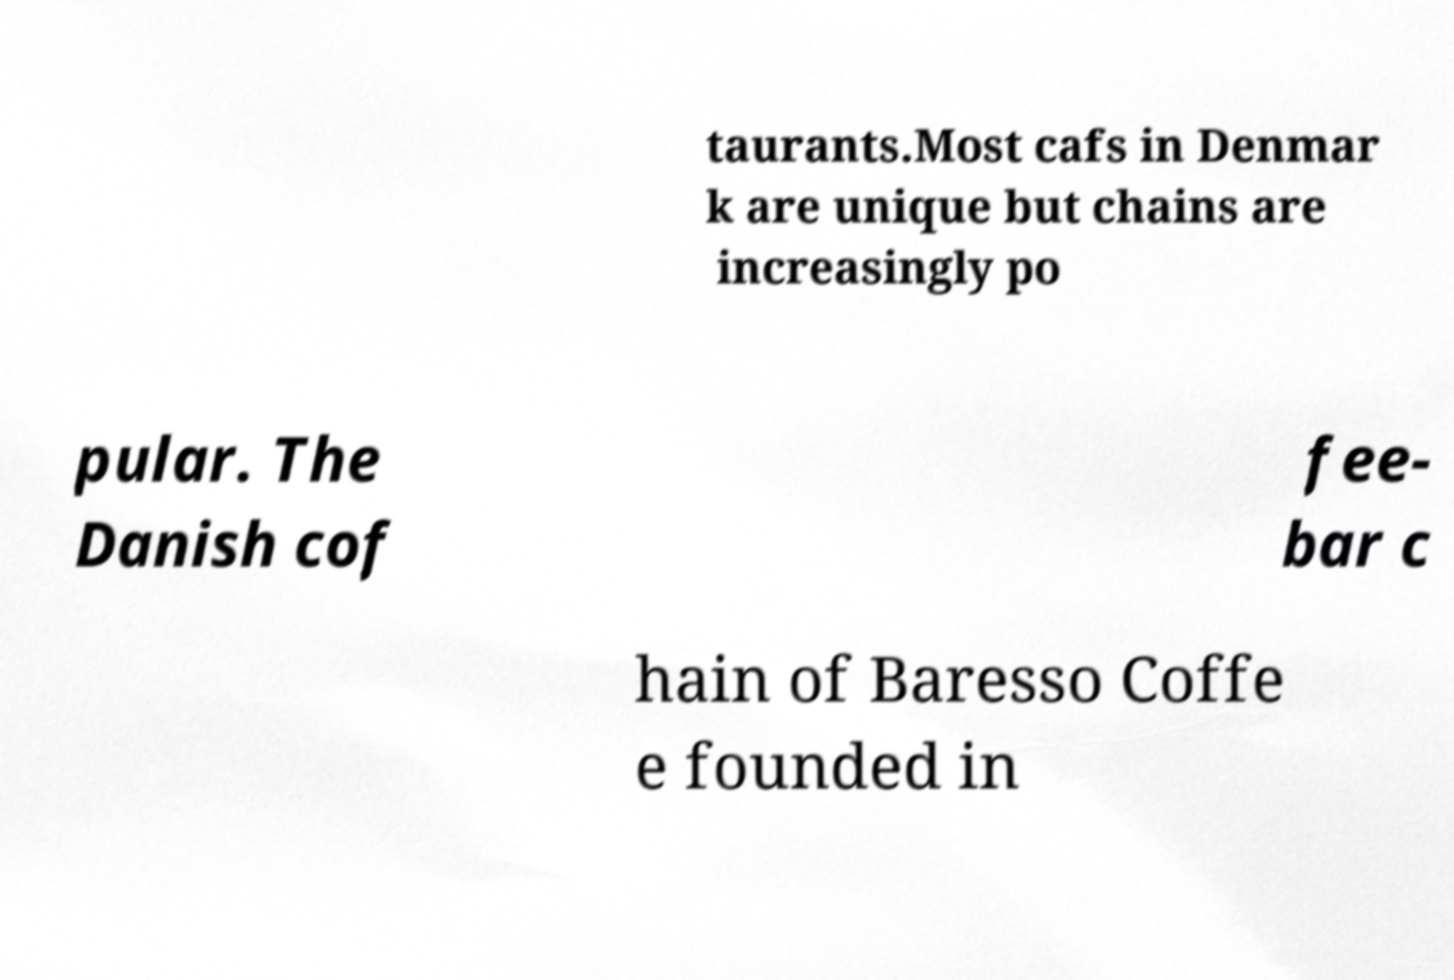Please read and relay the text visible in this image. What does it say? taurants.Most cafs in Denmar k are unique but chains are increasingly po pular. The Danish cof fee- bar c hain of Baresso Coffe e founded in 